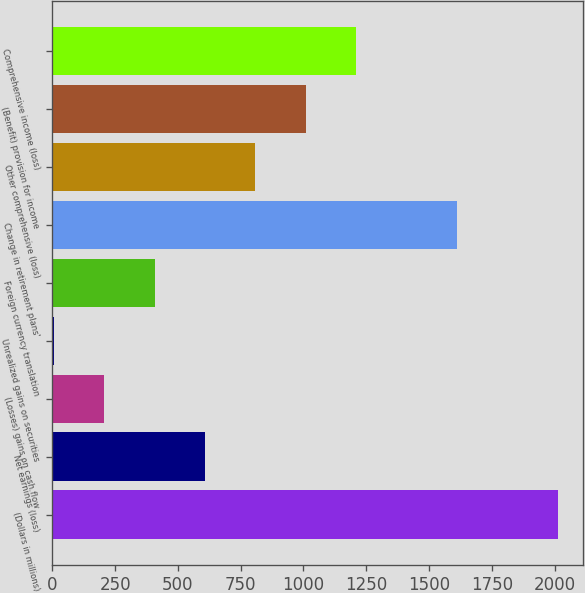Convert chart to OTSL. <chart><loc_0><loc_0><loc_500><loc_500><bar_chart><fcel>(Dollars in millions)<fcel>Net earnings (loss)<fcel>(Losses) gains on cash flow<fcel>Unrealized gains on securities<fcel>Foreign currency translation<fcel>Change in retirement plans'<fcel>Other comprehensive (loss)<fcel>(Benefit) provision for income<fcel>Comprehensive income (loss)<nl><fcel>2012<fcel>607.8<fcel>206.6<fcel>6<fcel>407.2<fcel>1610.8<fcel>808.4<fcel>1009<fcel>1209.6<nl></chart> 